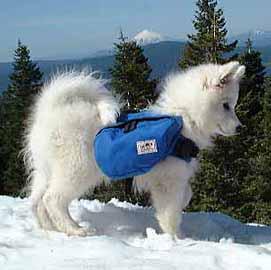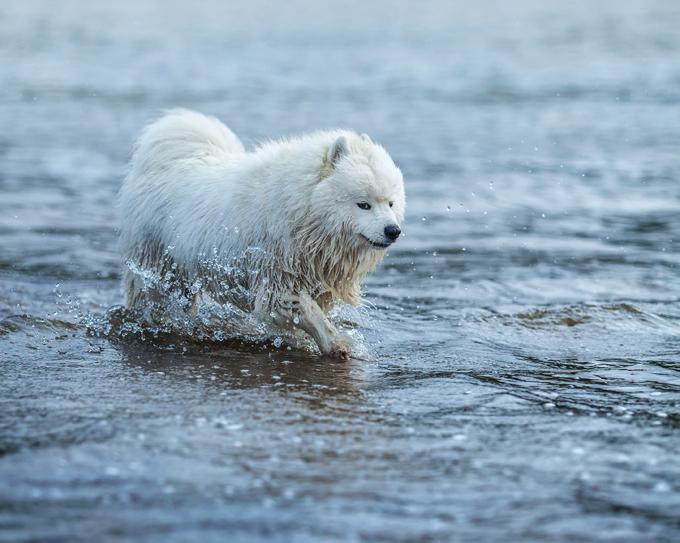The first image is the image on the left, the second image is the image on the right. Assess this claim about the two images: "There is exactly on dog in the image on the right.". Correct or not? Answer yes or no. Yes. 